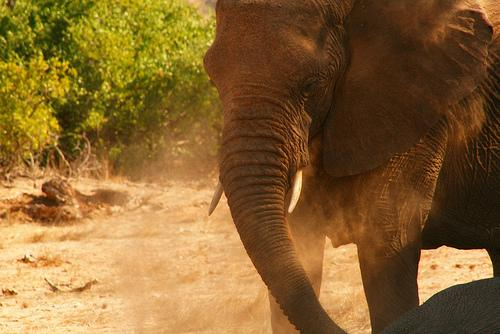Question: what is it blowing up?
Choices:
A. Leaves.
B. Dust.
C. Grass.
D. Dirt.
Answer with the letter. Answer: D Question: what color are the trees?
Choices:
A. Brown.
B. Orange.
C. Yellow.
D. Green.
Answer with the letter. Answer: D Question: what color are the tusks?
Choices:
A. White.
B. Grey.
C. Brown.
D. Yellow.
Answer with the letter. Answer: A Question: where are the tusks on its face?
Choices:
A. By its mouth.
B. Near the ears.
C. By the trunk.
D. Beside its head.
Answer with the letter. Answer: C Question: how many tusks do you see?
Choices:
A. Three.
B. One.
C. Four.
D. Two.
Answer with the letter. Answer: D 